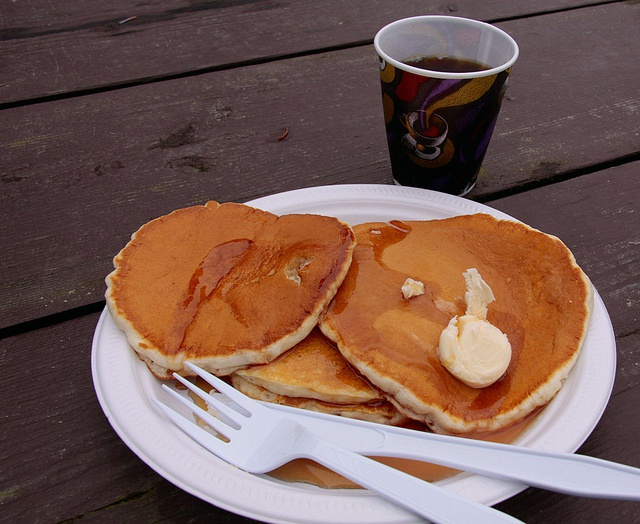Describe the objects in this image and their specific colors. I can see dining table in black, brown, gray, and lavender tones, cup in black, gray, and maroon tones, fork in black, lavender, darkgray, and maroon tones, and knife in black, lavender, darkgray, and lightgray tones in this image. 